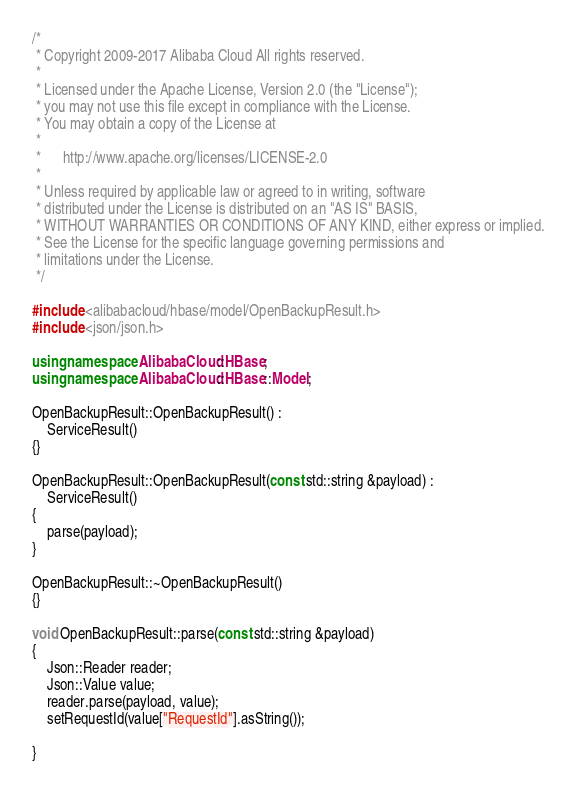<code> <loc_0><loc_0><loc_500><loc_500><_C++_>/*
 * Copyright 2009-2017 Alibaba Cloud All rights reserved.
 * 
 * Licensed under the Apache License, Version 2.0 (the "License");
 * you may not use this file except in compliance with the License.
 * You may obtain a copy of the License at
 * 
 *      http://www.apache.org/licenses/LICENSE-2.0
 * 
 * Unless required by applicable law or agreed to in writing, software
 * distributed under the License is distributed on an "AS IS" BASIS,
 * WITHOUT WARRANTIES OR CONDITIONS OF ANY KIND, either express or implied.
 * See the License for the specific language governing permissions and
 * limitations under the License.
 */

#include <alibabacloud/hbase/model/OpenBackupResult.h>
#include <json/json.h>

using namespace AlibabaCloud::HBase;
using namespace AlibabaCloud::HBase::Model;

OpenBackupResult::OpenBackupResult() :
	ServiceResult()
{}

OpenBackupResult::OpenBackupResult(const std::string &payload) :
	ServiceResult()
{
	parse(payload);
}

OpenBackupResult::~OpenBackupResult()
{}

void OpenBackupResult::parse(const std::string &payload)
{
	Json::Reader reader;
	Json::Value value;
	reader.parse(payload, value);
	setRequestId(value["RequestId"].asString());

}

</code> 